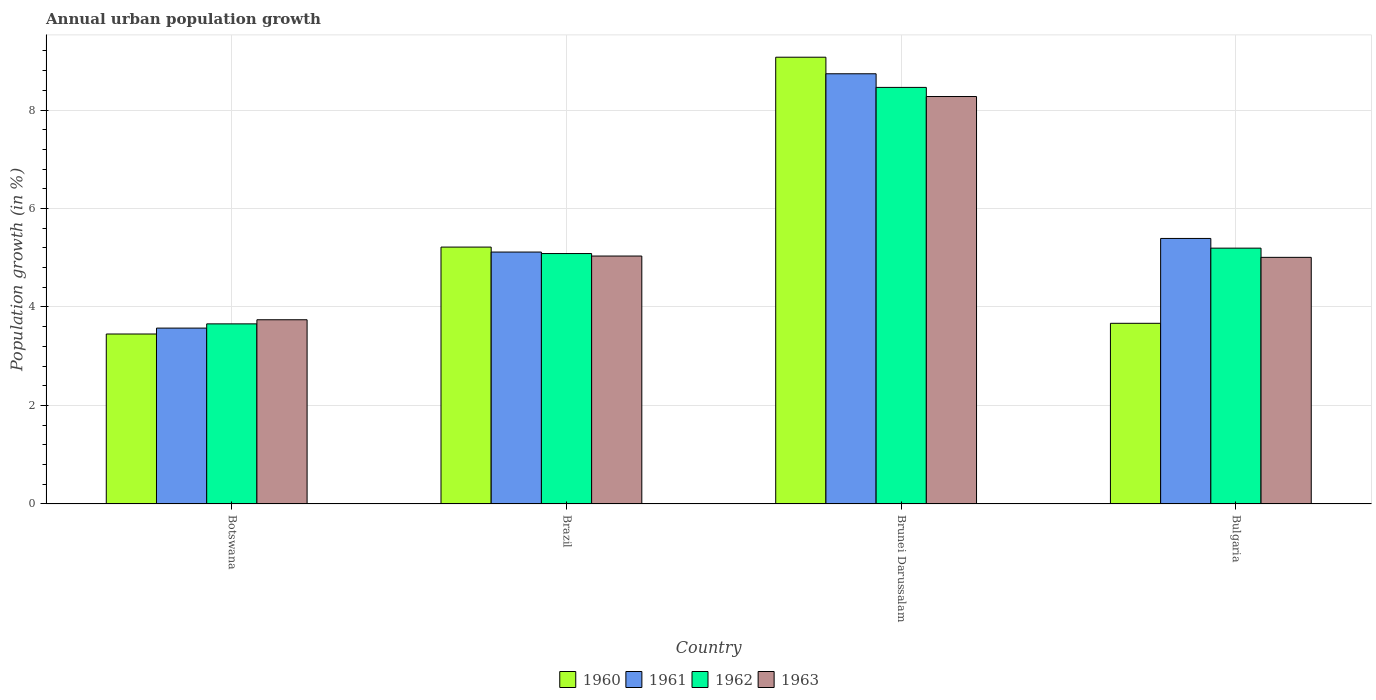How many groups of bars are there?
Make the answer very short. 4. How many bars are there on the 4th tick from the left?
Your response must be concise. 4. How many bars are there on the 2nd tick from the right?
Your answer should be very brief. 4. What is the label of the 4th group of bars from the left?
Your answer should be very brief. Bulgaria. What is the percentage of urban population growth in 1963 in Brunei Darussalam?
Offer a very short reply. 8.27. Across all countries, what is the maximum percentage of urban population growth in 1962?
Offer a very short reply. 8.46. Across all countries, what is the minimum percentage of urban population growth in 1963?
Offer a very short reply. 3.74. In which country was the percentage of urban population growth in 1960 maximum?
Offer a terse response. Brunei Darussalam. In which country was the percentage of urban population growth in 1961 minimum?
Keep it short and to the point. Botswana. What is the total percentage of urban population growth in 1960 in the graph?
Provide a succinct answer. 21.41. What is the difference between the percentage of urban population growth in 1960 in Botswana and that in Brunei Darussalam?
Give a very brief answer. -5.62. What is the difference between the percentage of urban population growth in 1962 in Brunei Darussalam and the percentage of urban population growth in 1960 in Botswana?
Provide a short and direct response. 5.01. What is the average percentage of urban population growth in 1963 per country?
Offer a very short reply. 5.51. What is the difference between the percentage of urban population growth of/in 1963 and percentage of urban population growth of/in 1961 in Brazil?
Ensure brevity in your answer.  -0.08. In how many countries, is the percentage of urban population growth in 1961 greater than 7.6 %?
Give a very brief answer. 1. What is the ratio of the percentage of urban population growth in 1961 in Brazil to that in Bulgaria?
Your response must be concise. 0.95. What is the difference between the highest and the second highest percentage of urban population growth in 1961?
Your response must be concise. 3.62. What is the difference between the highest and the lowest percentage of urban population growth in 1961?
Provide a succinct answer. 5.16. In how many countries, is the percentage of urban population growth in 1962 greater than the average percentage of urban population growth in 1962 taken over all countries?
Make the answer very short. 1. Is the sum of the percentage of urban population growth in 1960 in Botswana and Bulgaria greater than the maximum percentage of urban population growth in 1962 across all countries?
Your response must be concise. No. Is it the case that in every country, the sum of the percentage of urban population growth in 1960 and percentage of urban population growth in 1961 is greater than the sum of percentage of urban population growth in 1963 and percentage of urban population growth in 1962?
Give a very brief answer. No. What does the 3rd bar from the left in Botswana represents?
Make the answer very short. 1962. How many bars are there?
Keep it short and to the point. 16. Are all the bars in the graph horizontal?
Provide a succinct answer. No. How many countries are there in the graph?
Your response must be concise. 4. Are the values on the major ticks of Y-axis written in scientific E-notation?
Make the answer very short. No. Does the graph contain any zero values?
Keep it short and to the point. No. Does the graph contain grids?
Your answer should be compact. Yes. How many legend labels are there?
Ensure brevity in your answer.  4. What is the title of the graph?
Offer a terse response. Annual urban population growth. Does "2004" appear as one of the legend labels in the graph?
Keep it short and to the point. No. What is the label or title of the X-axis?
Ensure brevity in your answer.  Country. What is the label or title of the Y-axis?
Offer a terse response. Population growth (in %). What is the Population growth (in %) of 1960 in Botswana?
Give a very brief answer. 3.45. What is the Population growth (in %) in 1961 in Botswana?
Make the answer very short. 3.57. What is the Population growth (in %) of 1962 in Botswana?
Offer a terse response. 3.66. What is the Population growth (in %) in 1963 in Botswana?
Offer a very short reply. 3.74. What is the Population growth (in %) of 1960 in Brazil?
Your response must be concise. 5.22. What is the Population growth (in %) in 1961 in Brazil?
Your answer should be compact. 5.12. What is the Population growth (in %) of 1962 in Brazil?
Provide a short and direct response. 5.09. What is the Population growth (in %) of 1963 in Brazil?
Ensure brevity in your answer.  5.03. What is the Population growth (in %) of 1960 in Brunei Darussalam?
Your answer should be compact. 9.07. What is the Population growth (in %) in 1961 in Brunei Darussalam?
Your answer should be very brief. 8.74. What is the Population growth (in %) of 1962 in Brunei Darussalam?
Offer a very short reply. 8.46. What is the Population growth (in %) of 1963 in Brunei Darussalam?
Make the answer very short. 8.27. What is the Population growth (in %) of 1960 in Bulgaria?
Give a very brief answer. 3.67. What is the Population growth (in %) of 1961 in Bulgaria?
Your answer should be very brief. 5.39. What is the Population growth (in %) of 1962 in Bulgaria?
Your answer should be very brief. 5.2. What is the Population growth (in %) of 1963 in Bulgaria?
Make the answer very short. 5.01. Across all countries, what is the maximum Population growth (in %) of 1960?
Offer a terse response. 9.07. Across all countries, what is the maximum Population growth (in %) of 1961?
Keep it short and to the point. 8.74. Across all countries, what is the maximum Population growth (in %) in 1962?
Ensure brevity in your answer.  8.46. Across all countries, what is the maximum Population growth (in %) in 1963?
Ensure brevity in your answer.  8.27. Across all countries, what is the minimum Population growth (in %) in 1960?
Your response must be concise. 3.45. Across all countries, what is the minimum Population growth (in %) in 1961?
Offer a terse response. 3.57. Across all countries, what is the minimum Population growth (in %) in 1962?
Make the answer very short. 3.66. Across all countries, what is the minimum Population growth (in %) in 1963?
Your response must be concise. 3.74. What is the total Population growth (in %) in 1960 in the graph?
Your answer should be very brief. 21.41. What is the total Population growth (in %) of 1961 in the graph?
Your answer should be very brief. 22.82. What is the total Population growth (in %) of 1962 in the graph?
Your response must be concise. 22.4. What is the total Population growth (in %) in 1963 in the graph?
Your answer should be very brief. 22.06. What is the difference between the Population growth (in %) in 1960 in Botswana and that in Brazil?
Offer a very short reply. -1.76. What is the difference between the Population growth (in %) in 1961 in Botswana and that in Brazil?
Offer a terse response. -1.54. What is the difference between the Population growth (in %) in 1962 in Botswana and that in Brazil?
Offer a terse response. -1.43. What is the difference between the Population growth (in %) of 1963 in Botswana and that in Brazil?
Keep it short and to the point. -1.29. What is the difference between the Population growth (in %) of 1960 in Botswana and that in Brunei Darussalam?
Your answer should be very brief. -5.62. What is the difference between the Population growth (in %) in 1961 in Botswana and that in Brunei Darussalam?
Provide a short and direct response. -5.16. What is the difference between the Population growth (in %) in 1962 in Botswana and that in Brunei Darussalam?
Give a very brief answer. -4.8. What is the difference between the Population growth (in %) of 1963 in Botswana and that in Brunei Darussalam?
Provide a short and direct response. -4.53. What is the difference between the Population growth (in %) in 1960 in Botswana and that in Bulgaria?
Keep it short and to the point. -0.22. What is the difference between the Population growth (in %) in 1961 in Botswana and that in Bulgaria?
Provide a short and direct response. -1.82. What is the difference between the Population growth (in %) in 1962 in Botswana and that in Bulgaria?
Ensure brevity in your answer.  -1.54. What is the difference between the Population growth (in %) of 1963 in Botswana and that in Bulgaria?
Provide a succinct answer. -1.27. What is the difference between the Population growth (in %) in 1960 in Brazil and that in Brunei Darussalam?
Your response must be concise. -3.86. What is the difference between the Population growth (in %) in 1961 in Brazil and that in Brunei Darussalam?
Give a very brief answer. -3.62. What is the difference between the Population growth (in %) of 1962 in Brazil and that in Brunei Darussalam?
Offer a very short reply. -3.37. What is the difference between the Population growth (in %) of 1963 in Brazil and that in Brunei Darussalam?
Provide a succinct answer. -3.24. What is the difference between the Population growth (in %) in 1960 in Brazil and that in Bulgaria?
Your answer should be compact. 1.55. What is the difference between the Population growth (in %) in 1961 in Brazil and that in Bulgaria?
Keep it short and to the point. -0.28. What is the difference between the Population growth (in %) in 1962 in Brazil and that in Bulgaria?
Offer a very short reply. -0.11. What is the difference between the Population growth (in %) of 1963 in Brazil and that in Bulgaria?
Keep it short and to the point. 0.03. What is the difference between the Population growth (in %) in 1960 in Brunei Darussalam and that in Bulgaria?
Offer a very short reply. 5.4. What is the difference between the Population growth (in %) of 1961 in Brunei Darussalam and that in Bulgaria?
Your answer should be compact. 3.34. What is the difference between the Population growth (in %) of 1962 in Brunei Darussalam and that in Bulgaria?
Offer a terse response. 3.26. What is the difference between the Population growth (in %) of 1963 in Brunei Darussalam and that in Bulgaria?
Give a very brief answer. 3.27. What is the difference between the Population growth (in %) of 1960 in Botswana and the Population growth (in %) of 1961 in Brazil?
Provide a short and direct response. -1.66. What is the difference between the Population growth (in %) of 1960 in Botswana and the Population growth (in %) of 1962 in Brazil?
Your answer should be compact. -1.63. What is the difference between the Population growth (in %) in 1960 in Botswana and the Population growth (in %) in 1963 in Brazil?
Your response must be concise. -1.58. What is the difference between the Population growth (in %) of 1961 in Botswana and the Population growth (in %) of 1962 in Brazil?
Provide a short and direct response. -1.51. What is the difference between the Population growth (in %) of 1961 in Botswana and the Population growth (in %) of 1963 in Brazil?
Your response must be concise. -1.46. What is the difference between the Population growth (in %) of 1962 in Botswana and the Population growth (in %) of 1963 in Brazil?
Provide a short and direct response. -1.38. What is the difference between the Population growth (in %) in 1960 in Botswana and the Population growth (in %) in 1961 in Brunei Darussalam?
Offer a terse response. -5.28. What is the difference between the Population growth (in %) of 1960 in Botswana and the Population growth (in %) of 1962 in Brunei Darussalam?
Offer a very short reply. -5.01. What is the difference between the Population growth (in %) in 1960 in Botswana and the Population growth (in %) in 1963 in Brunei Darussalam?
Offer a terse response. -4.82. What is the difference between the Population growth (in %) in 1961 in Botswana and the Population growth (in %) in 1962 in Brunei Darussalam?
Offer a terse response. -4.89. What is the difference between the Population growth (in %) of 1961 in Botswana and the Population growth (in %) of 1963 in Brunei Darussalam?
Give a very brief answer. -4.7. What is the difference between the Population growth (in %) in 1962 in Botswana and the Population growth (in %) in 1963 in Brunei Darussalam?
Keep it short and to the point. -4.62. What is the difference between the Population growth (in %) in 1960 in Botswana and the Population growth (in %) in 1961 in Bulgaria?
Ensure brevity in your answer.  -1.94. What is the difference between the Population growth (in %) in 1960 in Botswana and the Population growth (in %) in 1962 in Bulgaria?
Provide a short and direct response. -1.74. What is the difference between the Population growth (in %) in 1960 in Botswana and the Population growth (in %) in 1963 in Bulgaria?
Offer a very short reply. -1.56. What is the difference between the Population growth (in %) in 1961 in Botswana and the Population growth (in %) in 1962 in Bulgaria?
Give a very brief answer. -1.62. What is the difference between the Population growth (in %) in 1961 in Botswana and the Population growth (in %) in 1963 in Bulgaria?
Make the answer very short. -1.44. What is the difference between the Population growth (in %) of 1962 in Botswana and the Population growth (in %) of 1963 in Bulgaria?
Provide a succinct answer. -1.35. What is the difference between the Population growth (in %) in 1960 in Brazil and the Population growth (in %) in 1961 in Brunei Darussalam?
Your response must be concise. -3.52. What is the difference between the Population growth (in %) of 1960 in Brazil and the Population growth (in %) of 1962 in Brunei Darussalam?
Provide a short and direct response. -3.24. What is the difference between the Population growth (in %) of 1960 in Brazil and the Population growth (in %) of 1963 in Brunei Darussalam?
Keep it short and to the point. -3.06. What is the difference between the Population growth (in %) of 1961 in Brazil and the Population growth (in %) of 1962 in Brunei Darussalam?
Provide a succinct answer. -3.34. What is the difference between the Population growth (in %) in 1961 in Brazil and the Population growth (in %) in 1963 in Brunei Darussalam?
Your answer should be compact. -3.16. What is the difference between the Population growth (in %) of 1962 in Brazil and the Population growth (in %) of 1963 in Brunei Darussalam?
Your answer should be compact. -3.19. What is the difference between the Population growth (in %) of 1960 in Brazil and the Population growth (in %) of 1961 in Bulgaria?
Your answer should be compact. -0.18. What is the difference between the Population growth (in %) in 1960 in Brazil and the Population growth (in %) in 1962 in Bulgaria?
Your response must be concise. 0.02. What is the difference between the Population growth (in %) of 1960 in Brazil and the Population growth (in %) of 1963 in Bulgaria?
Keep it short and to the point. 0.21. What is the difference between the Population growth (in %) of 1961 in Brazil and the Population growth (in %) of 1962 in Bulgaria?
Give a very brief answer. -0.08. What is the difference between the Population growth (in %) of 1961 in Brazil and the Population growth (in %) of 1963 in Bulgaria?
Offer a very short reply. 0.11. What is the difference between the Population growth (in %) in 1962 in Brazil and the Population growth (in %) in 1963 in Bulgaria?
Provide a short and direct response. 0.08. What is the difference between the Population growth (in %) of 1960 in Brunei Darussalam and the Population growth (in %) of 1961 in Bulgaria?
Offer a terse response. 3.68. What is the difference between the Population growth (in %) of 1960 in Brunei Darussalam and the Population growth (in %) of 1962 in Bulgaria?
Your answer should be very brief. 3.88. What is the difference between the Population growth (in %) in 1960 in Brunei Darussalam and the Population growth (in %) in 1963 in Bulgaria?
Your answer should be very brief. 4.06. What is the difference between the Population growth (in %) of 1961 in Brunei Darussalam and the Population growth (in %) of 1962 in Bulgaria?
Offer a very short reply. 3.54. What is the difference between the Population growth (in %) in 1961 in Brunei Darussalam and the Population growth (in %) in 1963 in Bulgaria?
Provide a short and direct response. 3.73. What is the difference between the Population growth (in %) in 1962 in Brunei Darussalam and the Population growth (in %) in 1963 in Bulgaria?
Your response must be concise. 3.45. What is the average Population growth (in %) in 1960 per country?
Ensure brevity in your answer.  5.35. What is the average Population growth (in %) in 1961 per country?
Provide a succinct answer. 5.7. What is the average Population growth (in %) of 1962 per country?
Make the answer very short. 5.6. What is the average Population growth (in %) of 1963 per country?
Your answer should be very brief. 5.51. What is the difference between the Population growth (in %) in 1960 and Population growth (in %) in 1961 in Botswana?
Your answer should be very brief. -0.12. What is the difference between the Population growth (in %) of 1960 and Population growth (in %) of 1962 in Botswana?
Your answer should be compact. -0.21. What is the difference between the Population growth (in %) of 1960 and Population growth (in %) of 1963 in Botswana?
Offer a terse response. -0.29. What is the difference between the Population growth (in %) in 1961 and Population growth (in %) in 1962 in Botswana?
Give a very brief answer. -0.09. What is the difference between the Population growth (in %) of 1961 and Population growth (in %) of 1963 in Botswana?
Make the answer very short. -0.17. What is the difference between the Population growth (in %) in 1962 and Population growth (in %) in 1963 in Botswana?
Give a very brief answer. -0.08. What is the difference between the Population growth (in %) in 1960 and Population growth (in %) in 1961 in Brazil?
Offer a very short reply. 0.1. What is the difference between the Population growth (in %) of 1960 and Population growth (in %) of 1962 in Brazil?
Your response must be concise. 0.13. What is the difference between the Population growth (in %) of 1960 and Population growth (in %) of 1963 in Brazil?
Give a very brief answer. 0.18. What is the difference between the Population growth (in %) of 1961 and Population growth (in %) of 1962 in Brazil?
Your answer should be very brief. 0.03. What is the difference between the Population growth (in %) of 1961 and Population growth (in %) of 1963 in Brazil?
Your answer should be very brief. 0.08. What is the difference between the Population growth (in %) of 1962 and Population growth (in %) of 1963 in Brazil?
Offer a very short reply. 0.05. What is the difference between the Population growth (in %) of 1960 and Population growth (in %) of 1961 in Brunei Darussalam?
Offer a very short reply. 0.34. What is the difference between the Population growth (in %) in 1960 and Population growth (in %) in 1962 in Brunei Darussalam?
Your answer should be very brief. 0.61. What is the difference between the Population growth (in %) in 1960 and Population growth (in %) in 1963 in Brunei Darussalam?
Ensure brevity in your answer.  0.8. What is the difference between the Population growth (in %) in 1961 and Population growth (in %) in 1962 in Brunei Darussalam?
Your response must be concise. 0.28. What is the difference between the Population growth (in %) of 1961 and Population growth (in %) of 1963 in Brunei Darussalam?
Ensure brevity in your answer.  0.46. What is the difference between the Population growth (in %) in 1962 and Population growth (in %) in 1963 in Brunei Darussalam?
Offer a terse response. 0.19. What is the difference between the Population growth (in %) in 1960 and Population growth (in %) in 1961 in Bulgaria?
Provide a short and direct response. -1.72. What is the difference between the Population growth (in %) in 1960 and Population growth (in %) in 1962 in Bulgaria?
Provide a succinct answer. -1.53. What is the difference between the Population growth (in %) in 1960 and Population growth (in %) in 1963 in Bulgaria?
Your answer should be compact. -1.34. What is the difference between the Population growth (in %) in 1961 and Population growth (in %) in 1962 in Bulgaria?
Your answer should be compact. 0.2. What is the difference between the Population growth (in %) in 1961 and Population growth (in %) in 1963 in Bulgaria?
Make the answer very short. 0.38. What is the difference between the Population growth (in %) in 1962 and Population growth (in %) in 1963 in Bulgaria?
Your response must be concise. 0.19. What is the ratio of the Population growth (in %) in 1960 in Botswana to that in Brazil?
Ensure brevity in your answer.  0.66. What is the ratio of the Population growth (in %) of 1961 in Botswana to that in Brazil?
Offer a very short reply. 0.7. What is the ratio of the Population growth (in %) in 1962 in Botswana to that in Brazil?
Keep it short and to the point. 0.72. What is the ratio of the Population growth (in %) of 1963 in Botswana to that in Brazil?
Provide a succinct answer. 0.74. What is the ratio of the Population growth (in %) in 1960 in Botswana to that in Brunei Darussalam?
Offer a terse response. 0.38. What is the ratio of the Population growth (in %) of 1961 in Botswana to that in Brunei Darussalam?
Offer a terse response. 0.41. What is the ratio of the Population growth (in %) of 1962 in Botswana to that in Brunei Darussalam?
Provide a succinct answer. 0.43. What is the ratio of the Population growth (in %) of 1963 in Botswana to that in Brunei Darussalam?
Offer a very short reply. 0.45. What is the ratio of the Population growth (in %) in 1960 in Botswana to that in Bulgaria?
Offer a terse response. 0.94. What is the ratio of the Population growth (in %) in 1961 in Botswana to that in Bulgaria?
Offer a very short reply. 0.66. What is the ratio of the Population growth (in %) of 1962 in Botswana to that in Bulgaria?
Your response must be concise. 0.7. What is the ratio of the Population growth (in %) in 1963 in Botswana to that in Bulgaria?
Your answer should be very brief. 0.75. What is the ratio of the Population growth (in %) of 1960 in Brazil to that in Brunei Darussalam?
Ensure brevity in your answer.  0.57. What is the ratio of the Population growth (in %) of 1961 in Brazil to that in Brunei Darussalam?
Your answer should be very brief. 0.59. What is the ratio of the Population growth (in %) in 1962 in Brazil to that in Brunei Darussalam?
Provide a short and direct response. 0.6. What is the ratio of the Population growth (in %) in 1963 in Brazil to that in Brunei Darussalam?
Make the answer very short. 0.61. What is the ratio of the Population growth (in %) of 1960 in Brazil to that in Bulgaria?
Provide a short and direct response. 1.42. What is the ratio of the Population growth (in %) of 1961 in Brazil to that in Bulgaria?
Offer a terse response. 0.95. What is the ratio of the Population growth (in %) of 1962 in Brazil to that in Bulgaria?
Provide a short and direct response. 0.98. What is the ratio of the Population growth (in %) in 1960 in Brunei Darussalam to that in Bulgaria?
Keep it short and to the point. 2.47. What is the ratio of the Population growth (in %) in 1961 in Brunei Darussalam to that in Bulgaria?
Ensure brevity in your answer.  1.62. What is the ratio of the Population growth (in %) in 1962 in Brunei Darussalam to that in Bulgaria?
Your answer should be compact. 1.63. What is the ratio of the Population growth (in %) in 1963 in Brunei Darussalam to that in Bulgaria?
Give a very brief answer. 1.65. What is the difference between the highest and the second highest Population growth (in %) of 1960?
Ensure brevity in your answer.  3.86. What is the difference between the highest and the second highest Population growth (in %) in 1961?
Give a very brief answer. 3.34. What is the difference between the highest and the second highest Population growth (in %) in 1962?
Provide a short and direct response. 3.26. What is the difference between the highest and the second highest Population growth (in %) in 1963?
Provide a short and direct response. 3.24. What is the difference between the highest and the lowest Population growth (in %) in 1960?
Ensure brevity in your answer.  5.62. What is the difference between the highest and the lowest Population growth (in %) in 1961?
Offer a terse response. 5.16. What is the difference between the highest and the lowest Population growth (in %) of 1962?
Provide a succinct answer. 4.8. What is the difference between the highest and the lowest Population growth (in %) in 1963?
Your response must be concise. 4.53. 